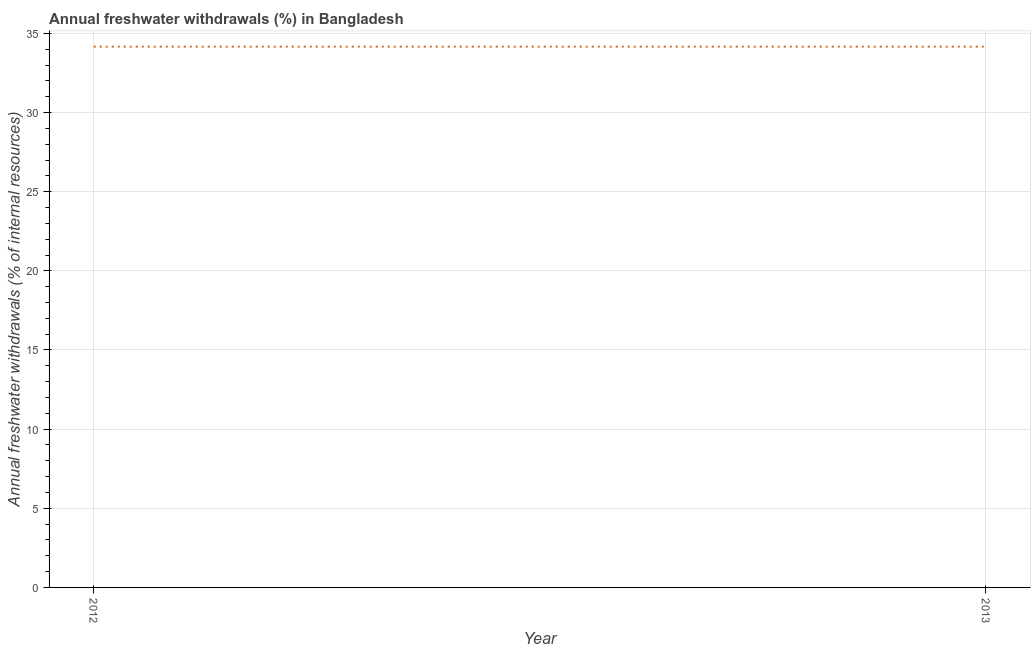What is the annual freshwater withdrawals in 2012?
Your answer should be compact. 34.16. Across all years, what is the maximum annual freshwater withdrawals?
Ensure brevity in your answer.  34.16. Across all years, what is the minimum annual freshwater withdrawals?
Give a very brief answer. 34.16. In which year was the annual freshwater withdrawals minimum?
Your answer should be very brief. 2012. What is the sum of the annual freshwater withdrawals?
Provide a succinct answer. 68.32. What is the average annual freshwater withdrawals per year?
Ensure brevity in your answer.  34.16. What is the median annual freshwater withdrawals?
Provide a succinct answer. 34.16. In how many years, is the annual freshwater withdrawals greater than 6 %?
Make the answer very short. 2. Do a majority of the years between 2013 and 2012 (inclusive) have annual freshwater withdrawals greater than 11 %?
Provide a succinct answer. No. What is the ratio of the annual freshwater withdrawals in 2012 to that in 2013?
Your response must be concise. 1. In how many years, is the annual freshwater withdrawals greater than the average annual freshwater withdrawals taken over all years?
Keep it short and to the point. 0. How many lines are there?
Your answer should be very brief. 1. What is the difference between two consecutive major ticks on the Y-axis?
Offer a terse response. 5. Does the graph contain any zero values?
Your response must be concise. No. What is the title of the graph?
Ensure brevity in your answer.  Annual freshwater withdrawals (%) in Bangladesh. What is the label or title of the X-axis?
Offer a terse response. Year. What is the label or title of the Y-axis?
Your answer should be very brief. Annual freshwater withdrawals (% of internal resources). What is the Annual freshwater withdrawals (% of internal resources) in 2012?
Make the answer very short. 34.16. What is the Annual freshwater withdrawals (% of internal resources) of 2013?
Ensure brevity in your answer.  34.16. What is the difference between the Annual freshwater withdrawals (% of internal resources) in 2012 and 2013?
Provide a succinct answer. 0. 